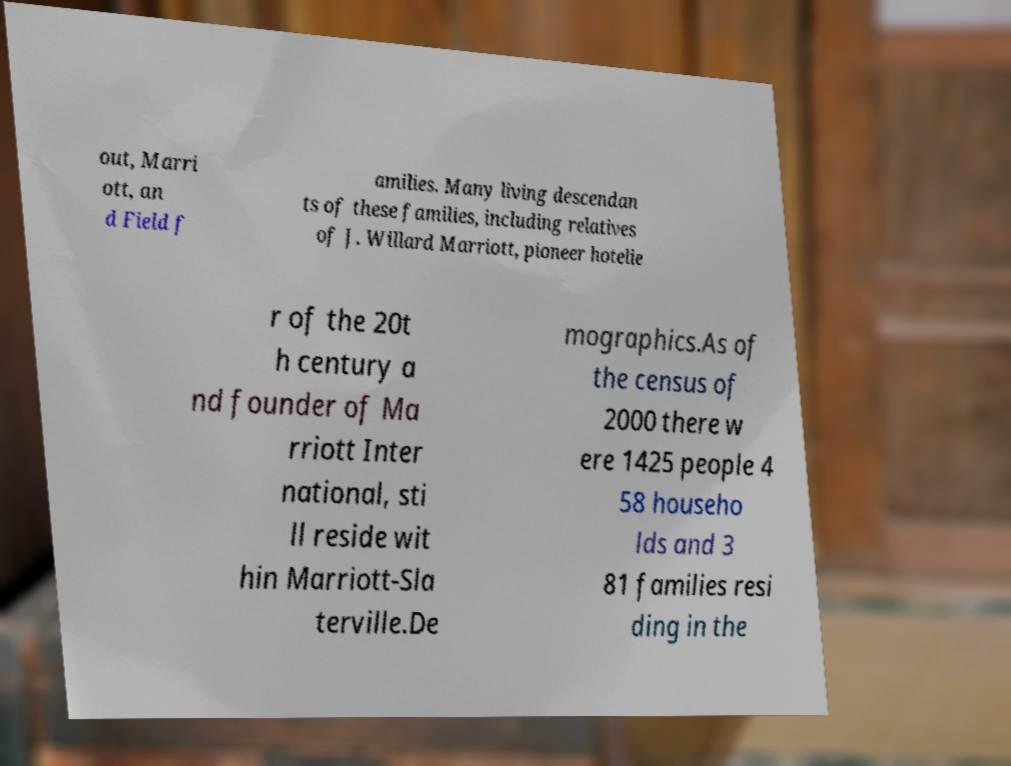I need the written content from this picture converted into text. Can you do that? out, Marri ott, an d Field f amilies. Many living descendan ts of these families, including relatives of J. Willard Marriott, pioneer hotelie r of the 20t h century a nd founder of Ma rriott Inter national, sti ll reside wit hin Marriott-Sla terville.De mographics.As of the census of 2000 there w ere 1425 people 4 58 househo lds and 3 81 families resi ding in the 